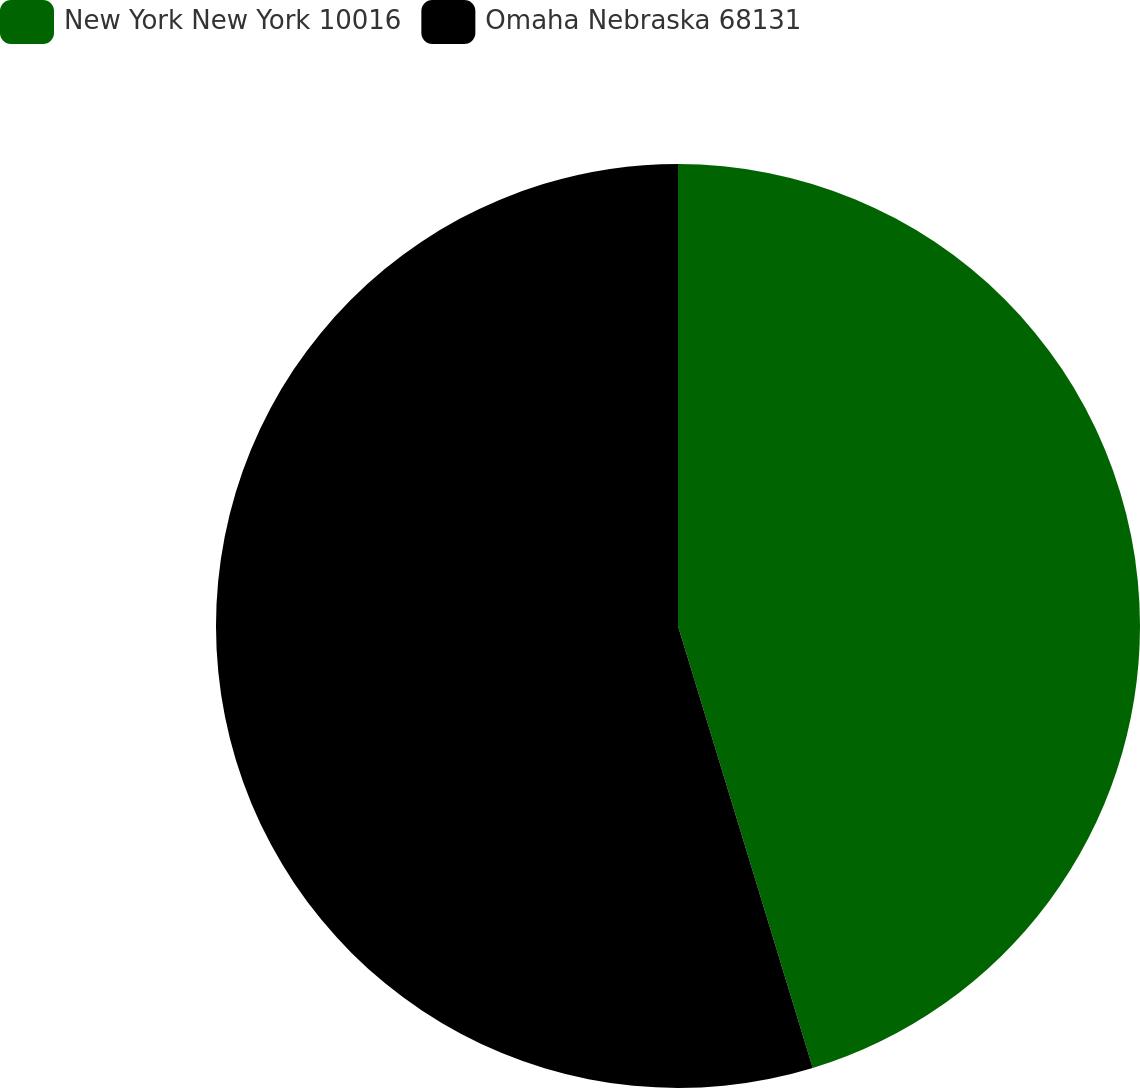<chart> <loc_0><loc_0><loc_500><loc_500><pie_chart><fcel>New York New York 10016<fcel>Omaha Nebraska 68131<nl><fcel>45.29%<fcel>54.71%<nl></chart> 